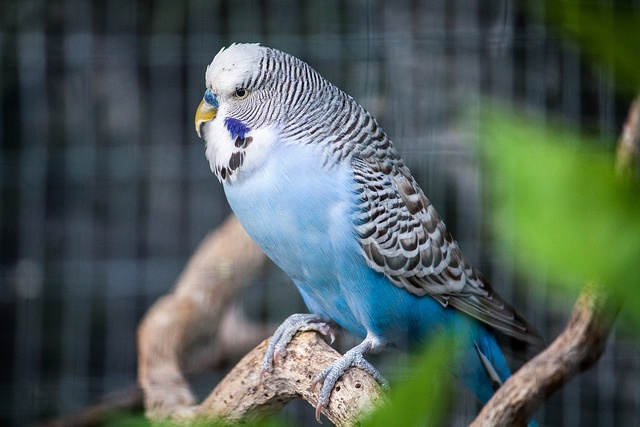Describe the objects in this image and their specific colors. I can see a bird in black, lavender, gray, and lightblue tones in this image. 